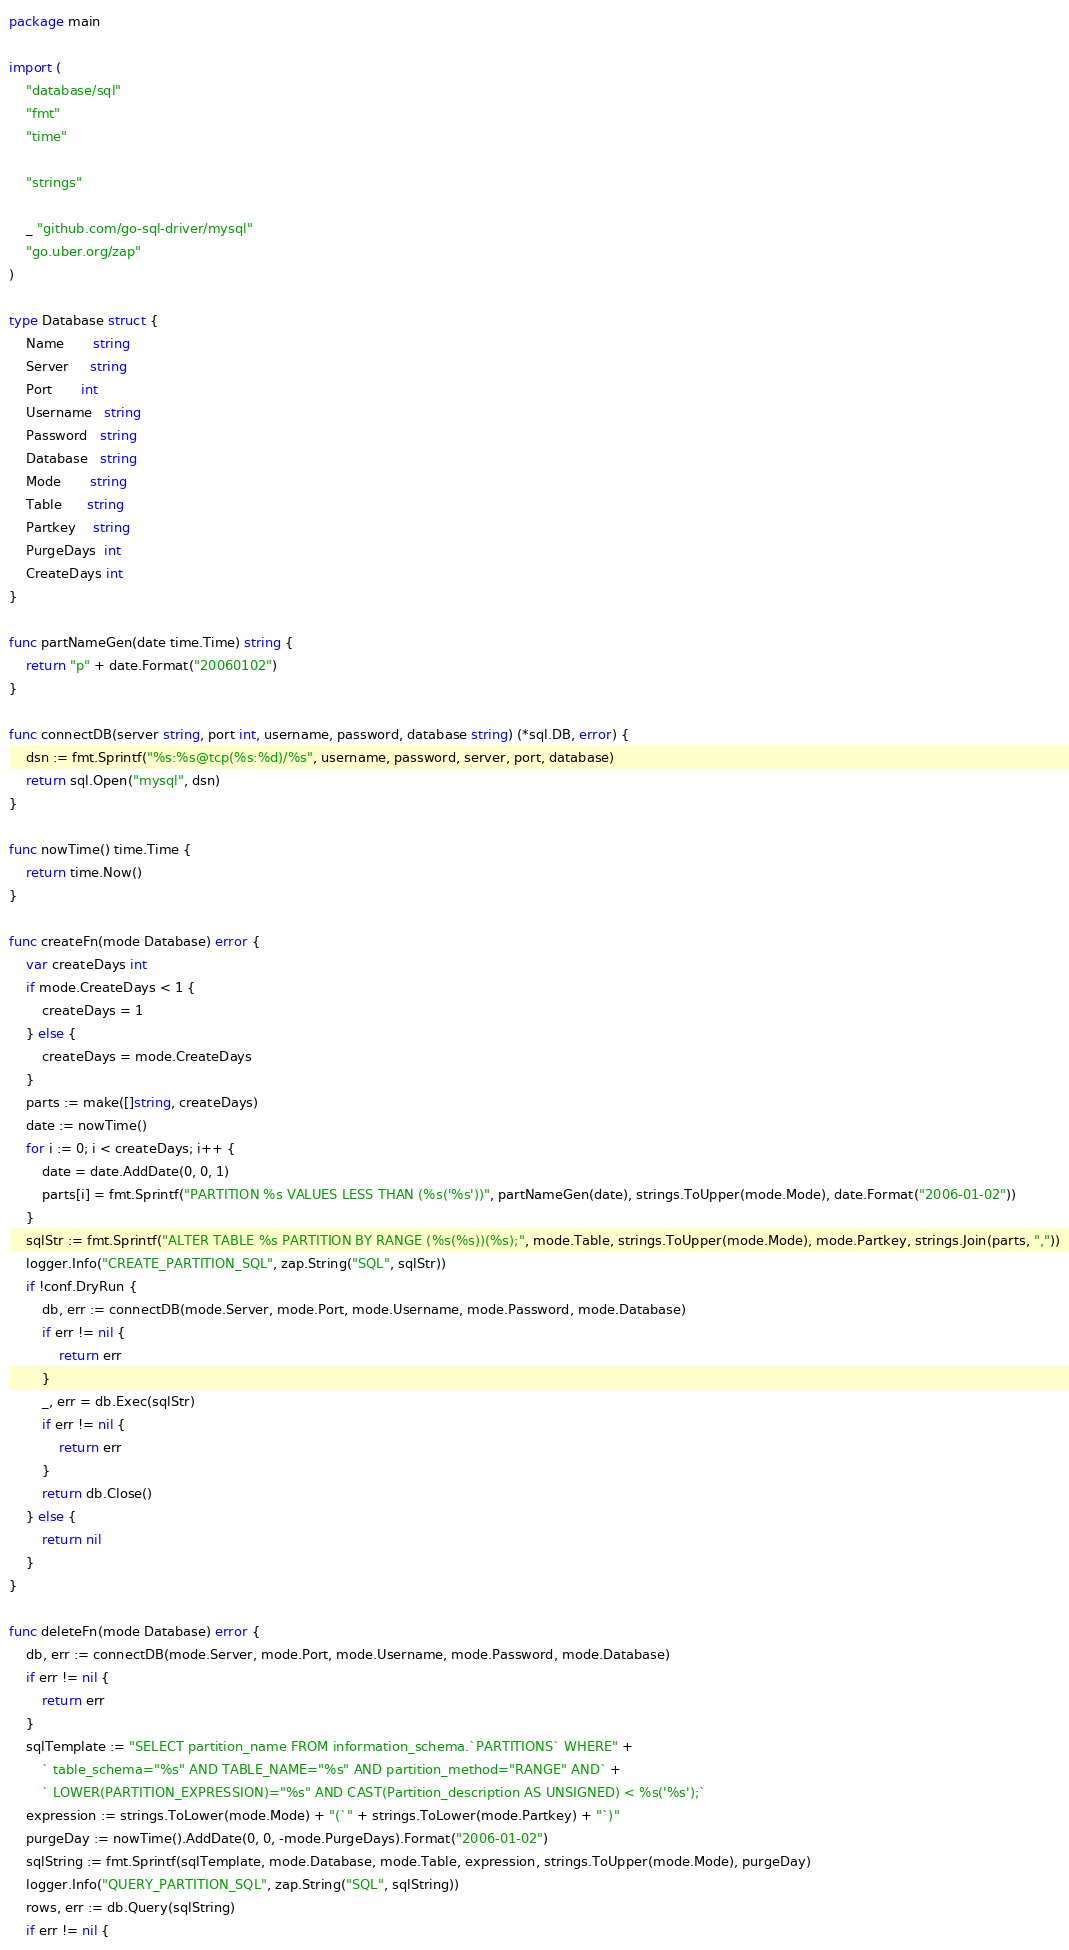<code> <loc_0><loc_0><loc_500><loc_500><_Go_>package main

import (
	"database/sql"
	"fmt"
	"time"

	"strings"

	_ "github.com/go-sql-driver/mysql"
	"go.uber.org/zap"
)

type Database struct {
	Name       string
	Server     string
	Port       int
	Username   string
	Password   string
	Database   string
	Mode       string
	Table      string
	Partkey    string
	PurgeDays  int
	CreateDays int
}

func partNameGen(date time.Time) string {
	return "p" + date.Format("20060102")
}

func connectDB(server string, port int, username, password, database string) (*sql.DB, error) {
	dsn := fmt.Sprintf("%s:%s@tcp(%s:%d)/%s", username, password, server, port, database)
	return sql.Open("mysql", dsn)
}

func nowTime() time.Time {
	return time.Now()
}

func createFn(mode Database) error {
	var createDays int
	if mode.CreateDays < 1 {
		createDays = 1
	} else {
		createDays = mode.CreateDays
	}
	parts := make([]string, createDays)
	date := nowTime()
	for i := 0; i < createDays; i++ {
		date = date.AddDate(0, 0, 1)
		parts[i] = fmt.Sprintf("PARTITION %s VALUES LESS THAN (%s('%s'))", partNameGen(date), strings.ToUpper(mode.Mode), date.Format("2006-01-02"))
	}
	sqlStr := fmt.Sprintf("ALTER TABLE %s PARTITION BY RANGE (%s(%s))(%s);", mode.Table, strings.ToUpper(mode.Mode), mode.Partkey, strings.Join(parts, ","))
	logger.Info("CREATE_PARTITION_SQL", zap.String("SQL", sqlStr))
	if !conf.DryRun {
		db, err := connectDB(mode.Server, mode.Port, mode.Username, mode.Password, mode.Database)
		if err != nil {
			return err
		}
		_, err = db.Exec(sqlStr)
		if err != nil {
			return err
		}
		return db.Close()
	} else {
		return nil
	}
}

func deleteFn(mode Database) error {
	db, err := connectDB(mode.Server, mode.Port, mode.Username, mode.Password, mode.Database)
	if err != nil {
		return err
	}
	sqlTemplate := "SELECT partition_name FROM information_schema.`PARTITIONS` WHERE" +
		` table_schema="%s" AND TABLE_NAME="%s" AND partition_method="RANGE" AND` +
		` LOWER(PARTITION_EXPRESSION)="%s" AND CAST(Partition_description AS UNSIGNED) < %s('%s');`
	expression := strings.ToLower(mode.Mode) + "(`" + strings.ToLower(mode.Partkey) + "`)"
	purgeDay := nowTime().AddDate(0, 0, -mode.PurgeDays).Format("2006-01-02")
	sqlString := fmt.Sprintf(sqlTemplate, mode.Database, mode.Table, expression, strings.ToUpper(mode.Mode), purgeDay)
	logger.Info("QUERY_PARTITION_SQL", zap.String("SQL", sqlString))
	rows, err := db.Query(sqlString)
	if err != nil {</code> 